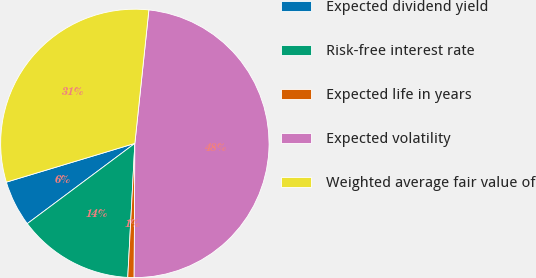<chart> <loc_0><loc_0><loc_500><loc_500><pie_chart><fcel>Expected dividend yield<fcel>Risk-free interest rate<fcel>Expected life in years<fcel>Expected volatility<fcel>Weighted average fair value of<nl><fcel>5.54%<fcel>13.96%<fcel>0.76%<fcel>48.42%<fcel>31.33%<nl></chart> 